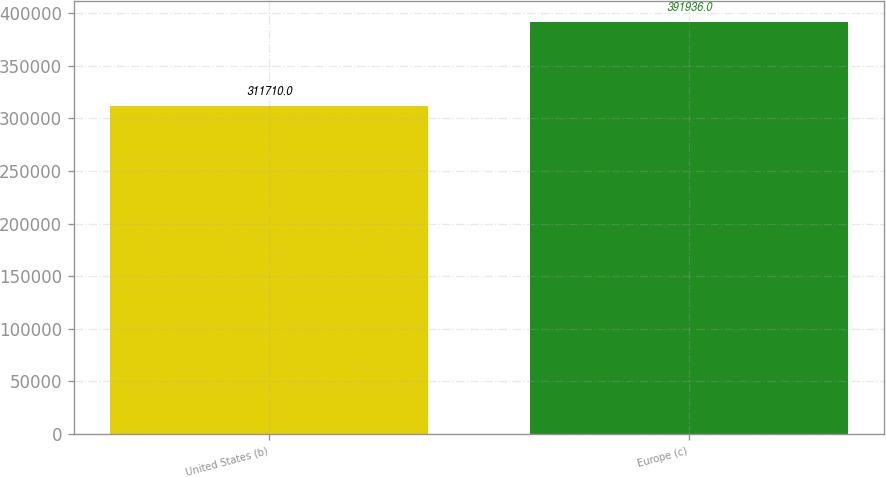Convert chart. <chart><loc_0><loc_0><loc_500><loc_500><bar_chart><fcel>United States (b)<fcel>Europe (c)<nl><fcel>311710<fcel>391936<nl></chart> 